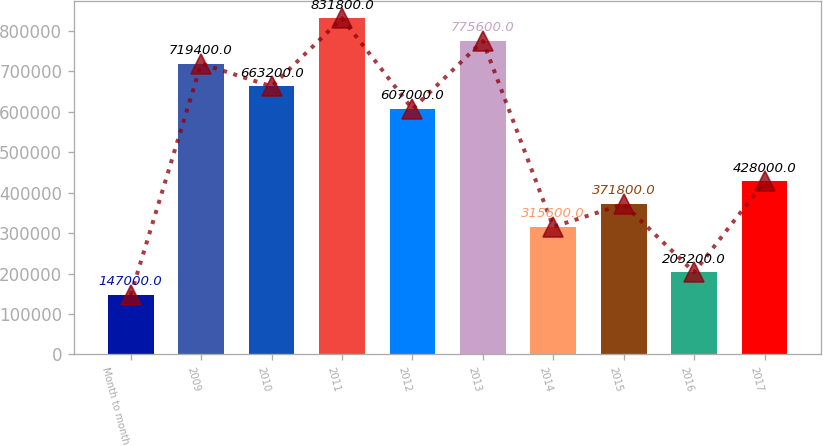<chart> <loc_0><loc_0><loc_500><loc_500><bar_chart><fcel>Month to month<fcel>2009<fcel>2010<fcel>2011<fcel>2012<fcel>2013<fcel>2014<fcel>2015<fcel>2016<fcel>2017<nl><fcel>147000<fcel>719400<fcel>663200<fcel>831800<fcel>607000<fcel>775600<fcel>315600<fcel>371800<fcel>203200<fcel>428000<nl></chart> 